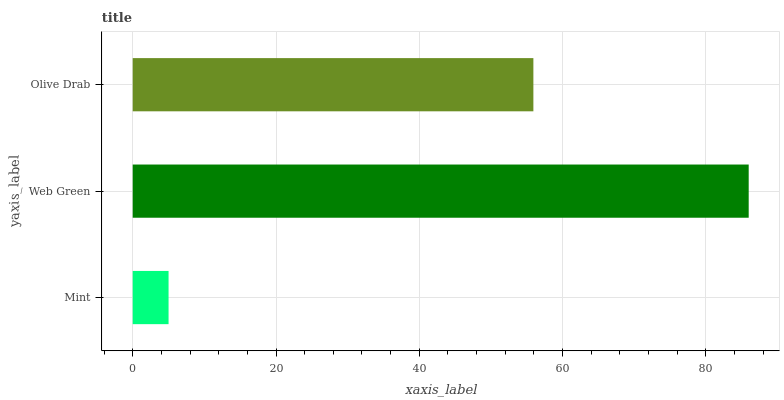Is Mint the minimum?
Answer yes or no. Yes. Is Web Green the maximum?
Answer yes or no. Yes. Is Olive Drab the minimum?
Answer yes or no. No. Is Olive Drab the maximum?
Answer yes or no. No. Is Web Green greater than Olive Drab?
Answer yes or no. Yes. Is Olive Drab less than Web Green?
Answer yes or no. Yes. Is Olive Drab greater than Web Green?
Answer yes or no. No. Is Web Green less than Olive Drab?
Answer yes or no. No. Is Olive Drab the high median?
Answer yes or no. Yes. Is Olive Drab the low median?
Answer yes or no. Yes. Is Web Green the high median?
Answer yes or no. No. Is Web Green the low median?
Answer yes or no. No. 